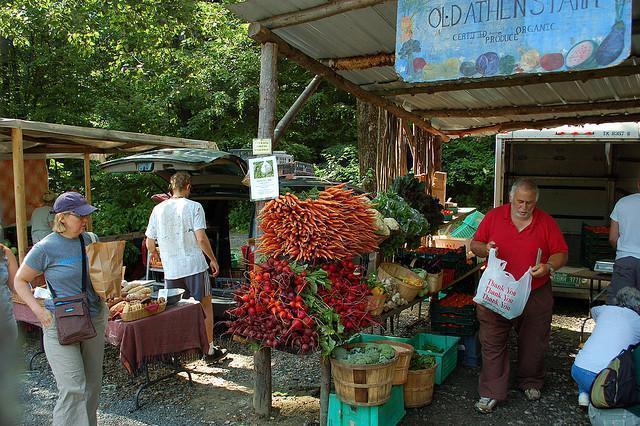Beta carotene rich vegetable in the image is?
Pick the correct solution from the four options below to address the question.
Options: Cabbage, broccoli, beet, carrot. Carrot. 